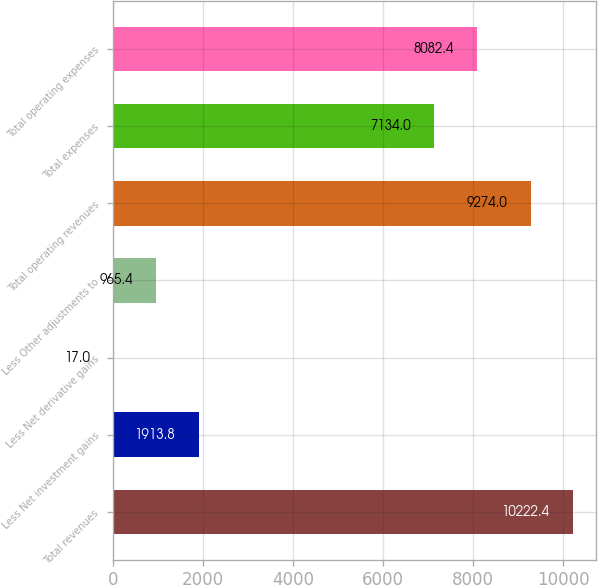<chart> <loc_0><loc_0><loc_500><loc_500><bar_chart><fcel>Total revenues<fcel>Less Net investment gains<fcel>Less Net derivative gains<fcel>Less Other adjustments to<fcel>Total operating revenues<fcel>Total expenses<fcel>Total operating expenses<nl><fcel>10222.4<fcel>1913.8<fcel>17<fcel>965.4<fcel>9274<fcel>7134<fcel>8082.4<nl></chart> 